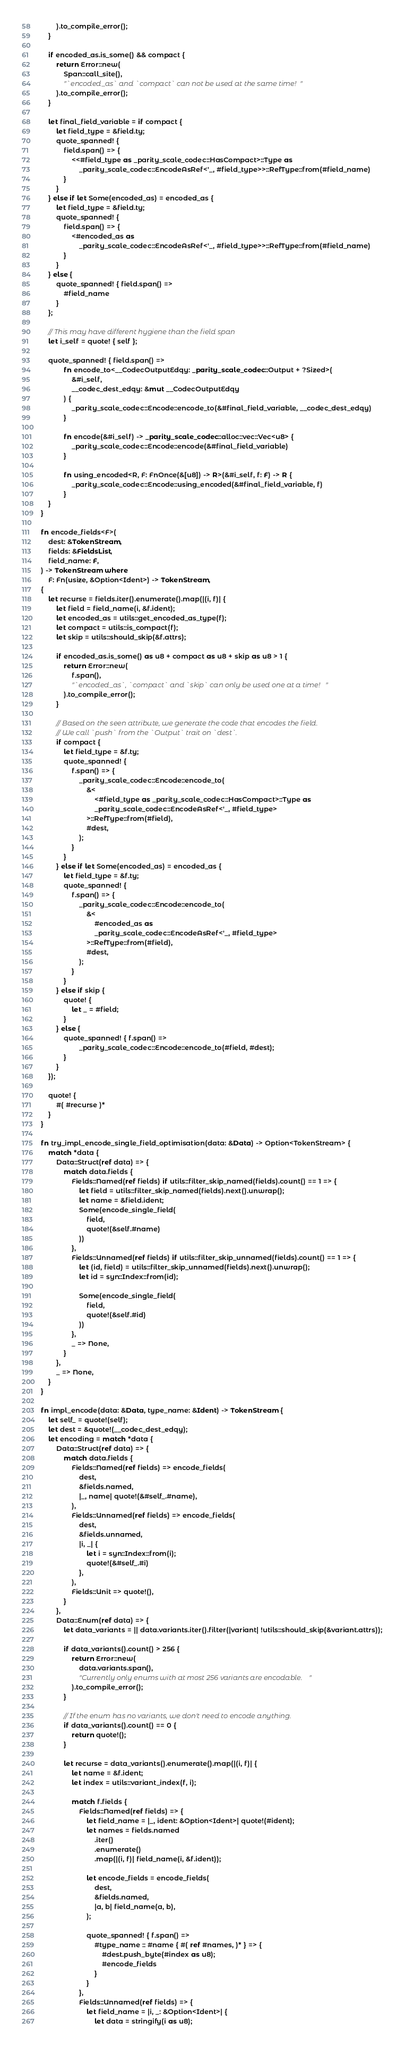<code> <loc_0><loc_0><loc_500><loc_500><_Rust_>		).to_compile_error();
	}

	if encoded_as.is_some() && compact {
		return Error::new(
			Span::call_site(),
			"`encoded_as` and `compact` can not be used at the same time!"
		).to_compile_error();
	}

	let final_field_variable = if compact {
		let field_type = &field.ty;
		quote_spanned! {
			field.span() => {
				<<#field_type as _parity_scale_codec::HasCompact>::Type as
					_parity_scale_codec::EncodeAsRef<'_, #field_type>>::RefType::from(#field_name)
			}
		}
	} else if let Some(encoded_as) = encoded_as {
		let field_type = &field.ty;
		quote_spanned! {
			field.span() => {
				<#encoded_as as
					_parity_scale_codec::EncodeAsRef<'_, #field_type>>::RefType::from(#field_name)
			}
		}
	} else {
		quote_spanned! { field.span() =>
			#field_name
		}
	};

	// This may have different hygiene than the field span
	let i_self = quote! { self };

	quote_spanned! { field.span() =>
			fn encode_to<__CodecOutputEdqy: _parity_scale_codec::Output + ?Sized>(
				&#i_self,
				__codec_dest_edqy: &mut __CodecOutputEdqy
			) {
				_parity_scale_codec::Encode::encode_to(&#final_field_variable, __codec_dest_edqy)
			}

			fn encode(&#i_self) -> _parity_scale_codec::alloc::vec::Vec<u8> {
				_parity_scale_codec::Encode::encode(&#final_field_variable)
			}

			fn using_encoded<R, F: FnOnce(&[u8]) -> R>(&#i_self, f: F) -> R {
				_parity_scale_codec::Encode::using_encoded(&#final_field_variable, f)
			}
	}
}

fn encode_fields<F>(
	dest: &TokenStream,
	fields: &FieldsList,
	field_name: F,
) -> TokenStream where
	F: Fn(usize, &Option<Ident>) -> TokenStream,
{
	let recurse = fields.iter().enumerate().map(|(i, f)| {
		let field = field_name(i, &f.ident);
		let encoded_as = utils::get_encoded_as_type(f);
		let compact = utils::is_compact(f);
		let skip = utils::should_skip(&f.attrs);

		if encoded_as.is_some() as u8 + compact as u8 + skip as u8 > 1 {
			return Error::new(
				f.span(),
				"`encoded_as`, `compact` and `skip` can only be used one at a time!"
			).to_compile_error();
		}

		// Based on the seen attribute, we generate the code that encodes the field.
		// We call `push` from the `Output` trait on `dest`.
		if compact {
			let field_type = &f.ty;
			quote_spanned! {
				f.span() => {
					_parity_scale_codec::Encode::encode_to(
						&<
							<#field_type as _parity_scale_codec::HasCompact>::Type as
							_parity_scale_codec::EncodeAsRef<'_, #field_type>
						>::RefType::from(#field),
						#dest,
					);
				}
			}
		} else if let Some(encoded_as) = encoded_as {
			let field_type = &f.ty;
			quote_spanned! {
				f.span() => {
					_parity_scale_codec::Encode::encode_to(
						&<
							#encoded_as as
							_parity_scale_codec::EncodeAsRef<'_, #field_type>
						>::RefType::from(#field),
						#dest,
					);
				}
			}
		} else if skip {
			quote! {
				let _ = #field;
			}
		} else {
			quote_spanned! { f.span() =>
					_parity_scale_codec::Encode::encode_to(#field, #dest);
			}
		}
	});

	quote! {
		#( #recurse )*
	}
}

fn try_impl_encode_single_field_optimisation(data: &Data) -> Option<TokenStream> {
	match *data {
		Data::Struct(ref data) => {
			match data.fields {
				Fields::Named(ref fields) if utils::filter_skip_named(fields).count() == 1 => {
					let field = utils::filter_skip_named(fields).next().unwrap();
					let name = &field.ident;
					Some(encode_single_field(
						field,
						quote!(&self.#name)
					))
				},
				Fields::Unnamed(ref fields) if utils::filter_skip_unnamed(fields).count() == 1 => {
					let (id, field) = utils::filter_skip_unnamed(fields).next().unwrap();
					let id = syn::Index::from(id);

					Some(encode_single_field(
						field,
						quote!(&self.#id)
					))
				},
				_ => None,
			}
		},
		_ => None,
	}
}

fn impl_encode(data: &Data, type_name: &Ident) -> TokenStream {
	let self_ = quote!(self);
	let dest = &quote!(__codec_dest_edqy);
	let encoding = match *data {
		Data::Struct(ref data) => {
			match data.fields {
				Fields::Named(ref fields) => encode_fields(
					dest,
					&fields.named,
					|_, name| quote!(&#self_.#name),
				),
				Fields::Unnamed(ref fields) => encode_fields(
					dest,
					&fields.unnamed,
					|i, _| {
						let i = syn::Index::from(i);
						quote!(&#self_.#i)
					},
				),
				Fields::Unit => quote!(),
			}
		},
		Data::Enum(ref data) => {
			let data_variants = || data.variants.iter().filter(|variant| !utils::should_skip(&variant.attrs));

			if data_variants().count() > 256 {
				return Error::new(
					data.variants.span(),
					"Currently only enums with at most 256 variants are encodable."
				).to_compile_error();
			}

			// If the enum has no variants, we don't need to encode anything.
			if data_variants().count() == 0 {
				return quote!();
			}

			let recurse = data_variants().enumerate().map(|(i, f)| {
				let name = &f.ident;
				let index = utils::variant_index(f, i);

				match f.fields {
					Fields::Named(ref fields) => {
						let field_name = |_, ident: &Option<Ident>| quote!(#ident);
						let names = fields.named
							.iter()
							.enumerate()
							.map(|(i, f)| field_name(i, &f.ident));

						let encode_fields = encode_fields(
							dest,
							&fields.named,
							|a, b| field_name(a, b),
						);

						quote_spanned! { f.span() =>
							#type_name :: #name { #( ref #names, )* } => {
								#dest.push_byte(#index as u8);
								#encode_fields
							}
						}
					},
					Fields::Unnamed(ref fields) => {
						let field_name = |i, _: &Option<Ident>| {
							let data = stringify(i as u8);</code> 